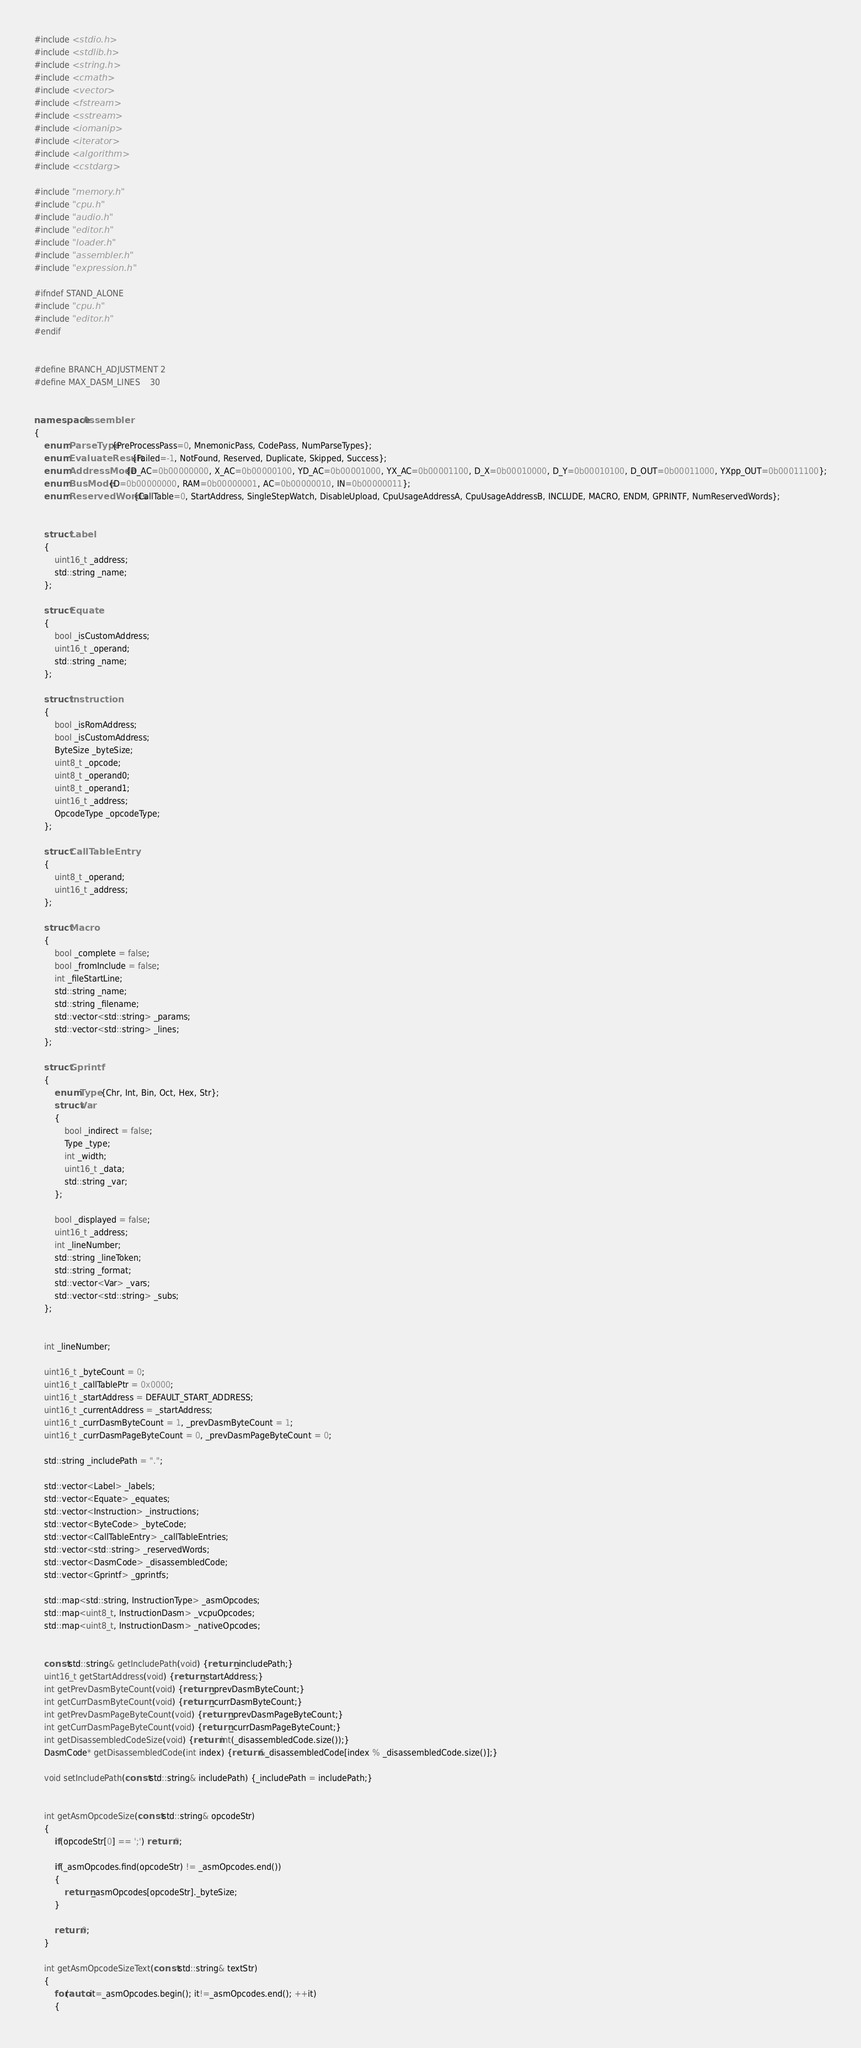<code> <loc_0><loc_0><loc_500><loc_500><_C++_>#include <stdio.h>
#include <stdlib.h>
#include <string.h>
#include <cmath>
#include <vector>
#include <fstream>
#include <sstream>
#include <iomanip>
#include <iterator>
#include <algorithm>
#include <cstdarg>

#include "memory.h"
#include "cpu.h"
#include "audio.h"
#include "editor.h"
#include "loader.h"
#include "assembler.h"
#include "expression.h"

#ifndef STAND_ALONE
#include "cpu.h"
#include "editor.h"
#endif


#define BRANCH_ADJUSTMENT 2
#define MAX_DASM_LINES    30


namespace Assembler
{
    enum ParseType {PreProcessPass=0, MnemonicPass, CodePass, NumParseTypes};
    enum EvaluateResult {Failed=-1, NotFound, Reserved, Duplicate, Skipped, Success};
    enum AddressMode {D_AC=0b00000000, X_AC=0b00000100, YD_AC=0b00001000, YX_AC=0b00001100, D_X=0b00010000, D_Y=0b00010100, D_OUT=0b00011000, YXpp_OUT=0b00011100};
    enum BusMode {D=0b00000000, RAM=0b00000001, AC=0b00000010, IN=0b00000011};
    enum ReservedWords {CallTable=0, StartAddress, SingleStepWatch, DisableUpload, CpuUsageAddressA, CpuUsageAddressB, INCLUDE, MACRO, ENDM, GPRINTF, NumReservedWords};


    struct Label
    {
        uint16_t _address;
        std::string _name;
    };

    struct Equate
    {
        bool _isCustomAddress;
        uint16_t _operand;
        std::string _name;
    };

    struct Instruction
    {
        bool _isRomAddress;
        bool _isCustomAddress;
        ByteSize _byteSize;
        uint8_t _opcode;
        uint8_t _operand0;
        uint8_t _operand1;
        uint16_t _address;
        OpcodeType _opcodeType;
    };

    struct CallTableEntry
    {
        uint8_t _operand;
        uint16_t _address;
    };

    struct Macro
    {
        bool _complete = false;
        bool _fromInclude = false;
        int _fileStartLine;
        std::string _name;
        std::string _filename;
        std::vector<std::string> _params;
        std::vector<std::string> _lines;
    };

    struct Gprintf
    {
        enum Type {Chr, Int, Bin, Oct, Hex, Str};
        struct Var
        {
            bool _indirect = false;
            Type _type;
            int _width;
            uint16_t _data;
            std::string _var;
        };

        bool _displayed = false;
        uint16_t _address;
        int _lineNumber;
        std::string _lineToken;
        std::string _format;
        std::vector<Var> _vars;
        std::vector<std::string> _subs;
    };


    int _lineNumber;

    uint16_t _byteCount = 0;
    uint16_t _callTablePtr = 0x0000;
    uint16_t _startAddress = DEFAULT_START_ADDRESS;
    uint16_t _currentAddress = _startAddress;
    uint16_t _currDasmByteCount = 1, _prevDasmByteCount = 1;
    uint16_t _currDasmPageByteCount = 0, _prevDasmPageByteCount = 0;

    std::string _includePath = ".";

    std::vector<Label> _labels;
    std::vector<Equate> _equates;
    std::vector<Instruction> _instructions;
    std::vector<ByteCode> _byteCode;
    std::vector<CallTableEntry> _callTableEntries;
    std::vector<std::string> _reservedWords;
    std::vector<DasmCode> _disassembledCode;
    std::vector<Gprintf> _gprintfs;

    std::map<std::string, InstructionType> _asmOpcodes;
    std::map<uint8_t, InstructionDasm> _vcpuOpcodes;
    std::map<uint8_t, InstructionDasm> _nativeOpcodes;


    const std::string& getIncludePath(void) {return _includePath;}
    uint16_t getStartAddress(void) {return _startAddress;}
    int getPrevDasmByteCount(void) {return _prevDasmByteCount;}
    int getCurrDasmByteCount(void) {return _currDasmByteCount;}
    int getPrevDasmPageByteCount(void) {return _prevDasmPageByteCount;}
    int getCurrDasmPageByteCount(void) {return _currDasmPageByteCount;}
    int getDisassembledCodeSize(void) {return int(_disassembledCode.size());}
    DasmCode* getDisassembledCode(int index) {return &_disassembledCode[index % _disassembledCode.size()];}

    void setIncludePath(const std::string& includePath) {_includePath = includePath;}


    int getAsmOpcodeSize(const std::string& opcodeStr)
    {
        if(opcodeStr[0] == ';') return 0;

        if(_asmOpcodes.find(opcodeStr) != _asmOpcodes.end())
        {
            return _asmOpcodes[opcodeStr]._byteSize;
        }

        return 0;
    }

    int getAsmOpcodeSizeText(const std::string& textStr)
    {
        for(auto it=_asmOpcodes.begin(); it!=_asmOpcodes.end(); ++it)
        {</code> 